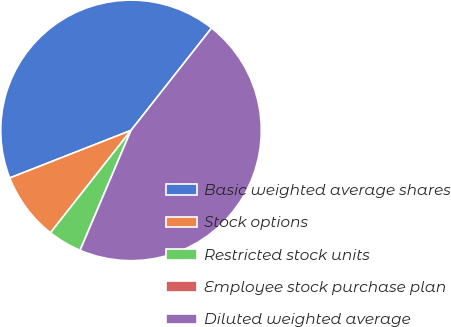Convert chart to OTSL. <chart><loc_0><loc_0><loc_500><loc_500><pie_chart><fcel>Basic weighted average shares<fcel>Stock options<fcel>Restricted stock units<fcel>Employee stock purchase plan<fcel>Diluted weighted average<nl><fcel>41.56%<fcel>8.44%<fcel>4.22%<fcel>0.0%<fcel>45.78%<nl></chart> 